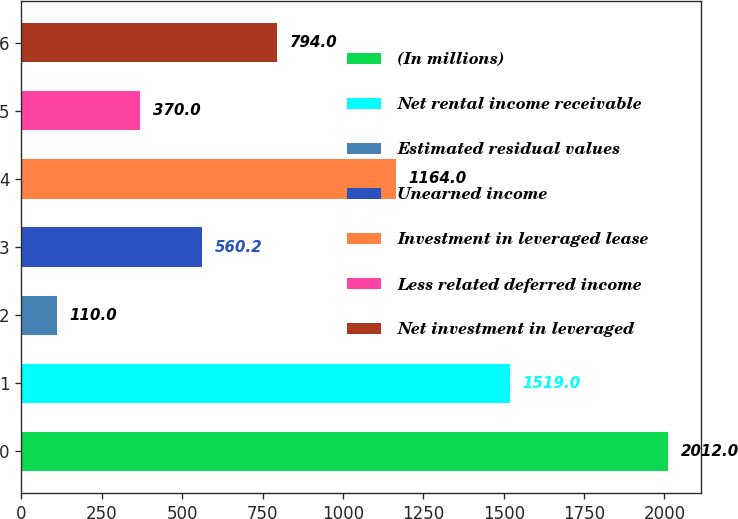<chart> <loc_0><loc_0><loc_500><loc_500><bar_chart><fcel>(In millions)<fcel>Net rental income receivable<fcel>Estimated residual values<fcel>Unearned income<fcel>Investment in leveraged lease<fcel>Less related deferred income<fcel>Net investment in leveraged<nl><fcel>2012<fcel>1519<fcel>110<fcel>560.2<fcel>1164<fcel>370<fcel>794<nl></chart> 